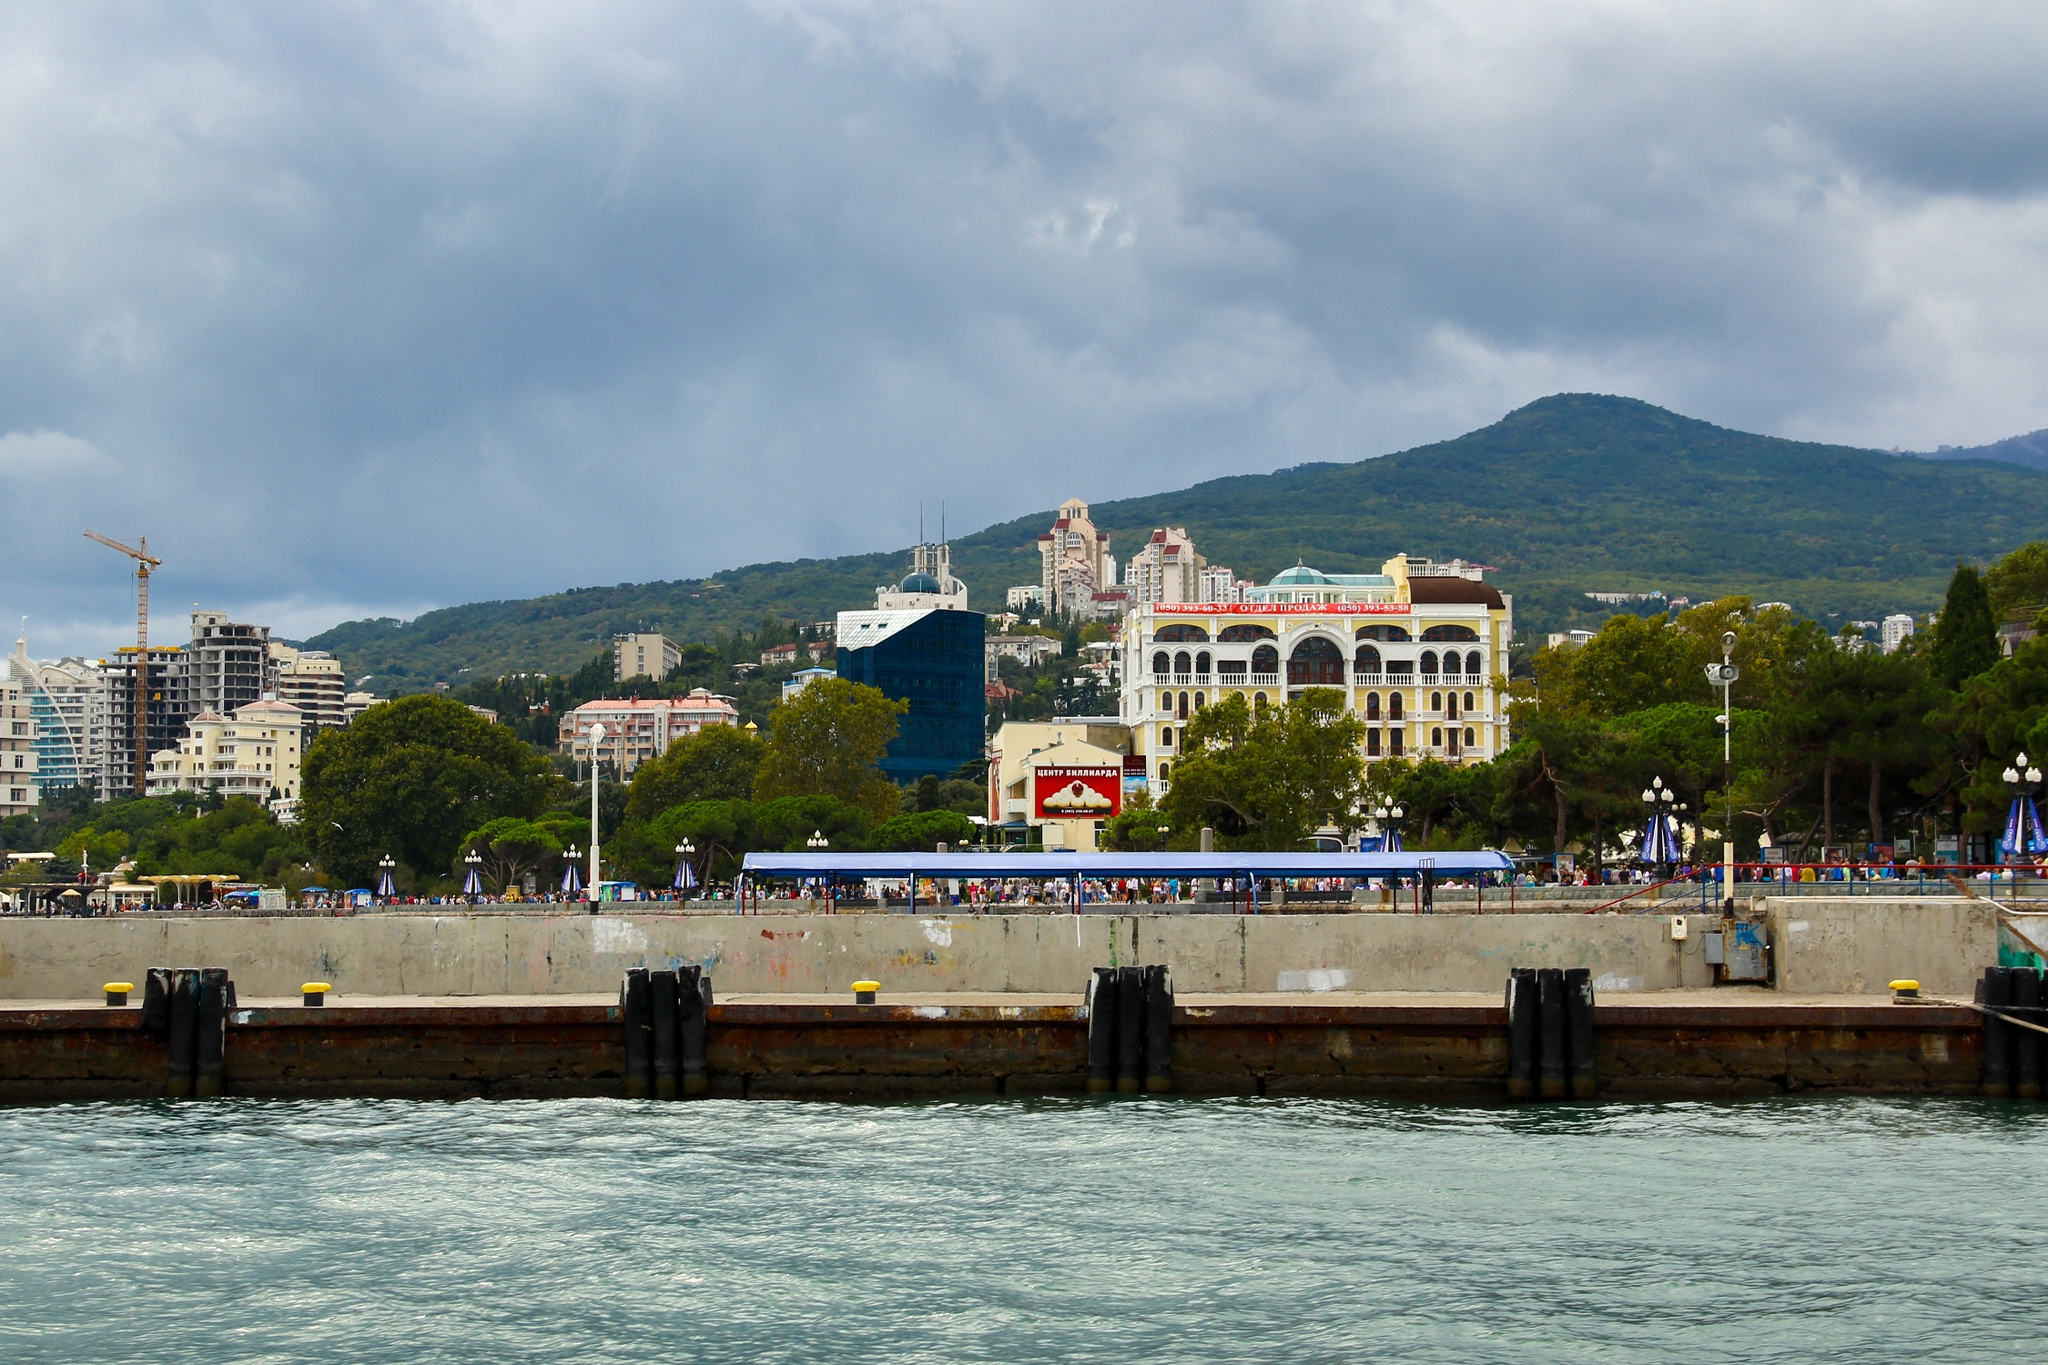What is the atmosphere like in this image? The atmosphere in the image is lively and vibrant. The pier is bustling with people, creating a sense of dynamic activity and excitement. The diverse architecture of the buildings adds a distinct cultural richness, while the surrounding natural beauty of the hills and the soft light from the cloudy sky contribute to a calm and serene backdrop. Overall, the scene combines the energy of a busy seafront with the tranquility of nature, capturing a balanced and appealing ambiance. 